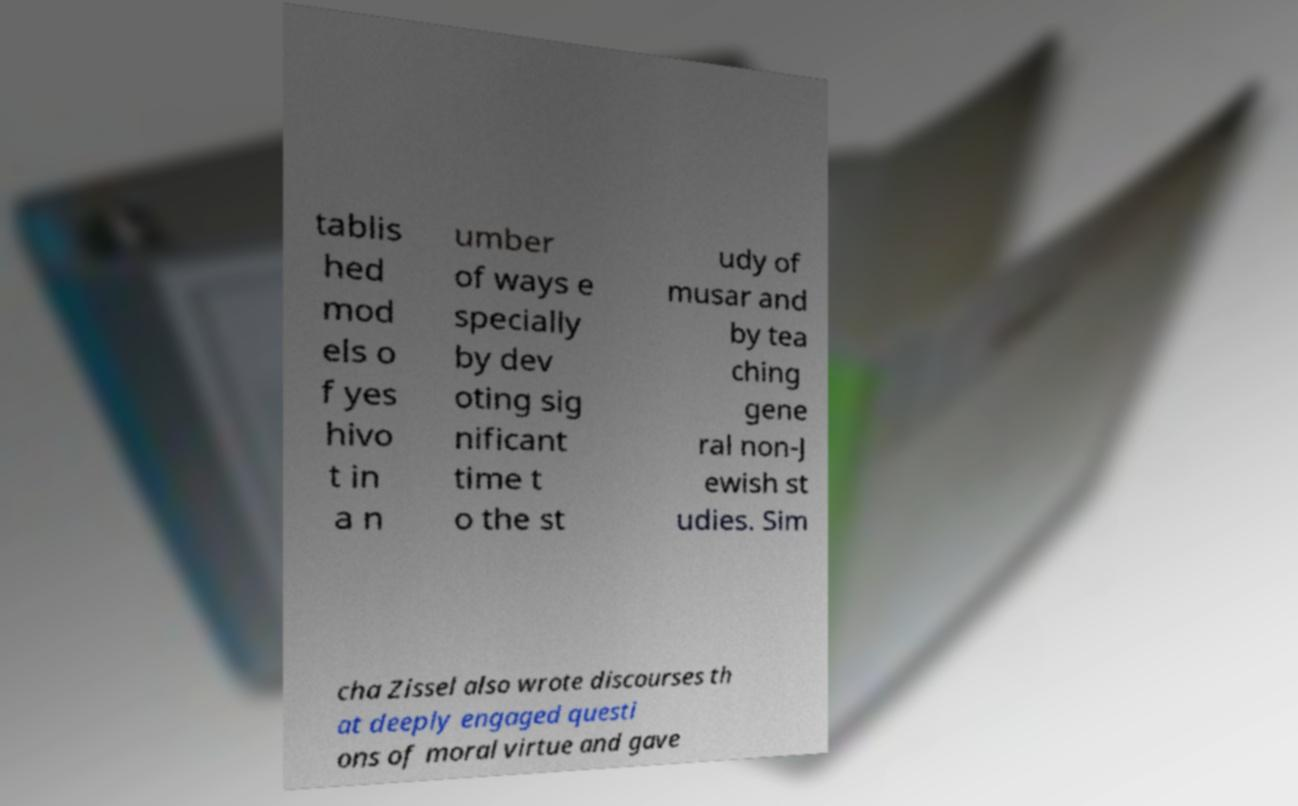There's text embedded in this image that I need extracted. Can you transcribe it verbatim? tablis hed mod els o f yes hivo t in a n umber of ways e specially by dev oting sig nificant time t o the st udy of musar and by tea ching gene ral non-J ewish st udies. Sim cha Zissel also wrote discourses th at deeply engaged questi ons of moral virtue and gave 